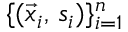Convert formula to latex. <formula><loc_0><loc_0><loc_500><loc_500>\{ ( \vec { x } _ { i } , \, s _ { i } ) \} _ { i = 1 } ^ { n }</formula> 